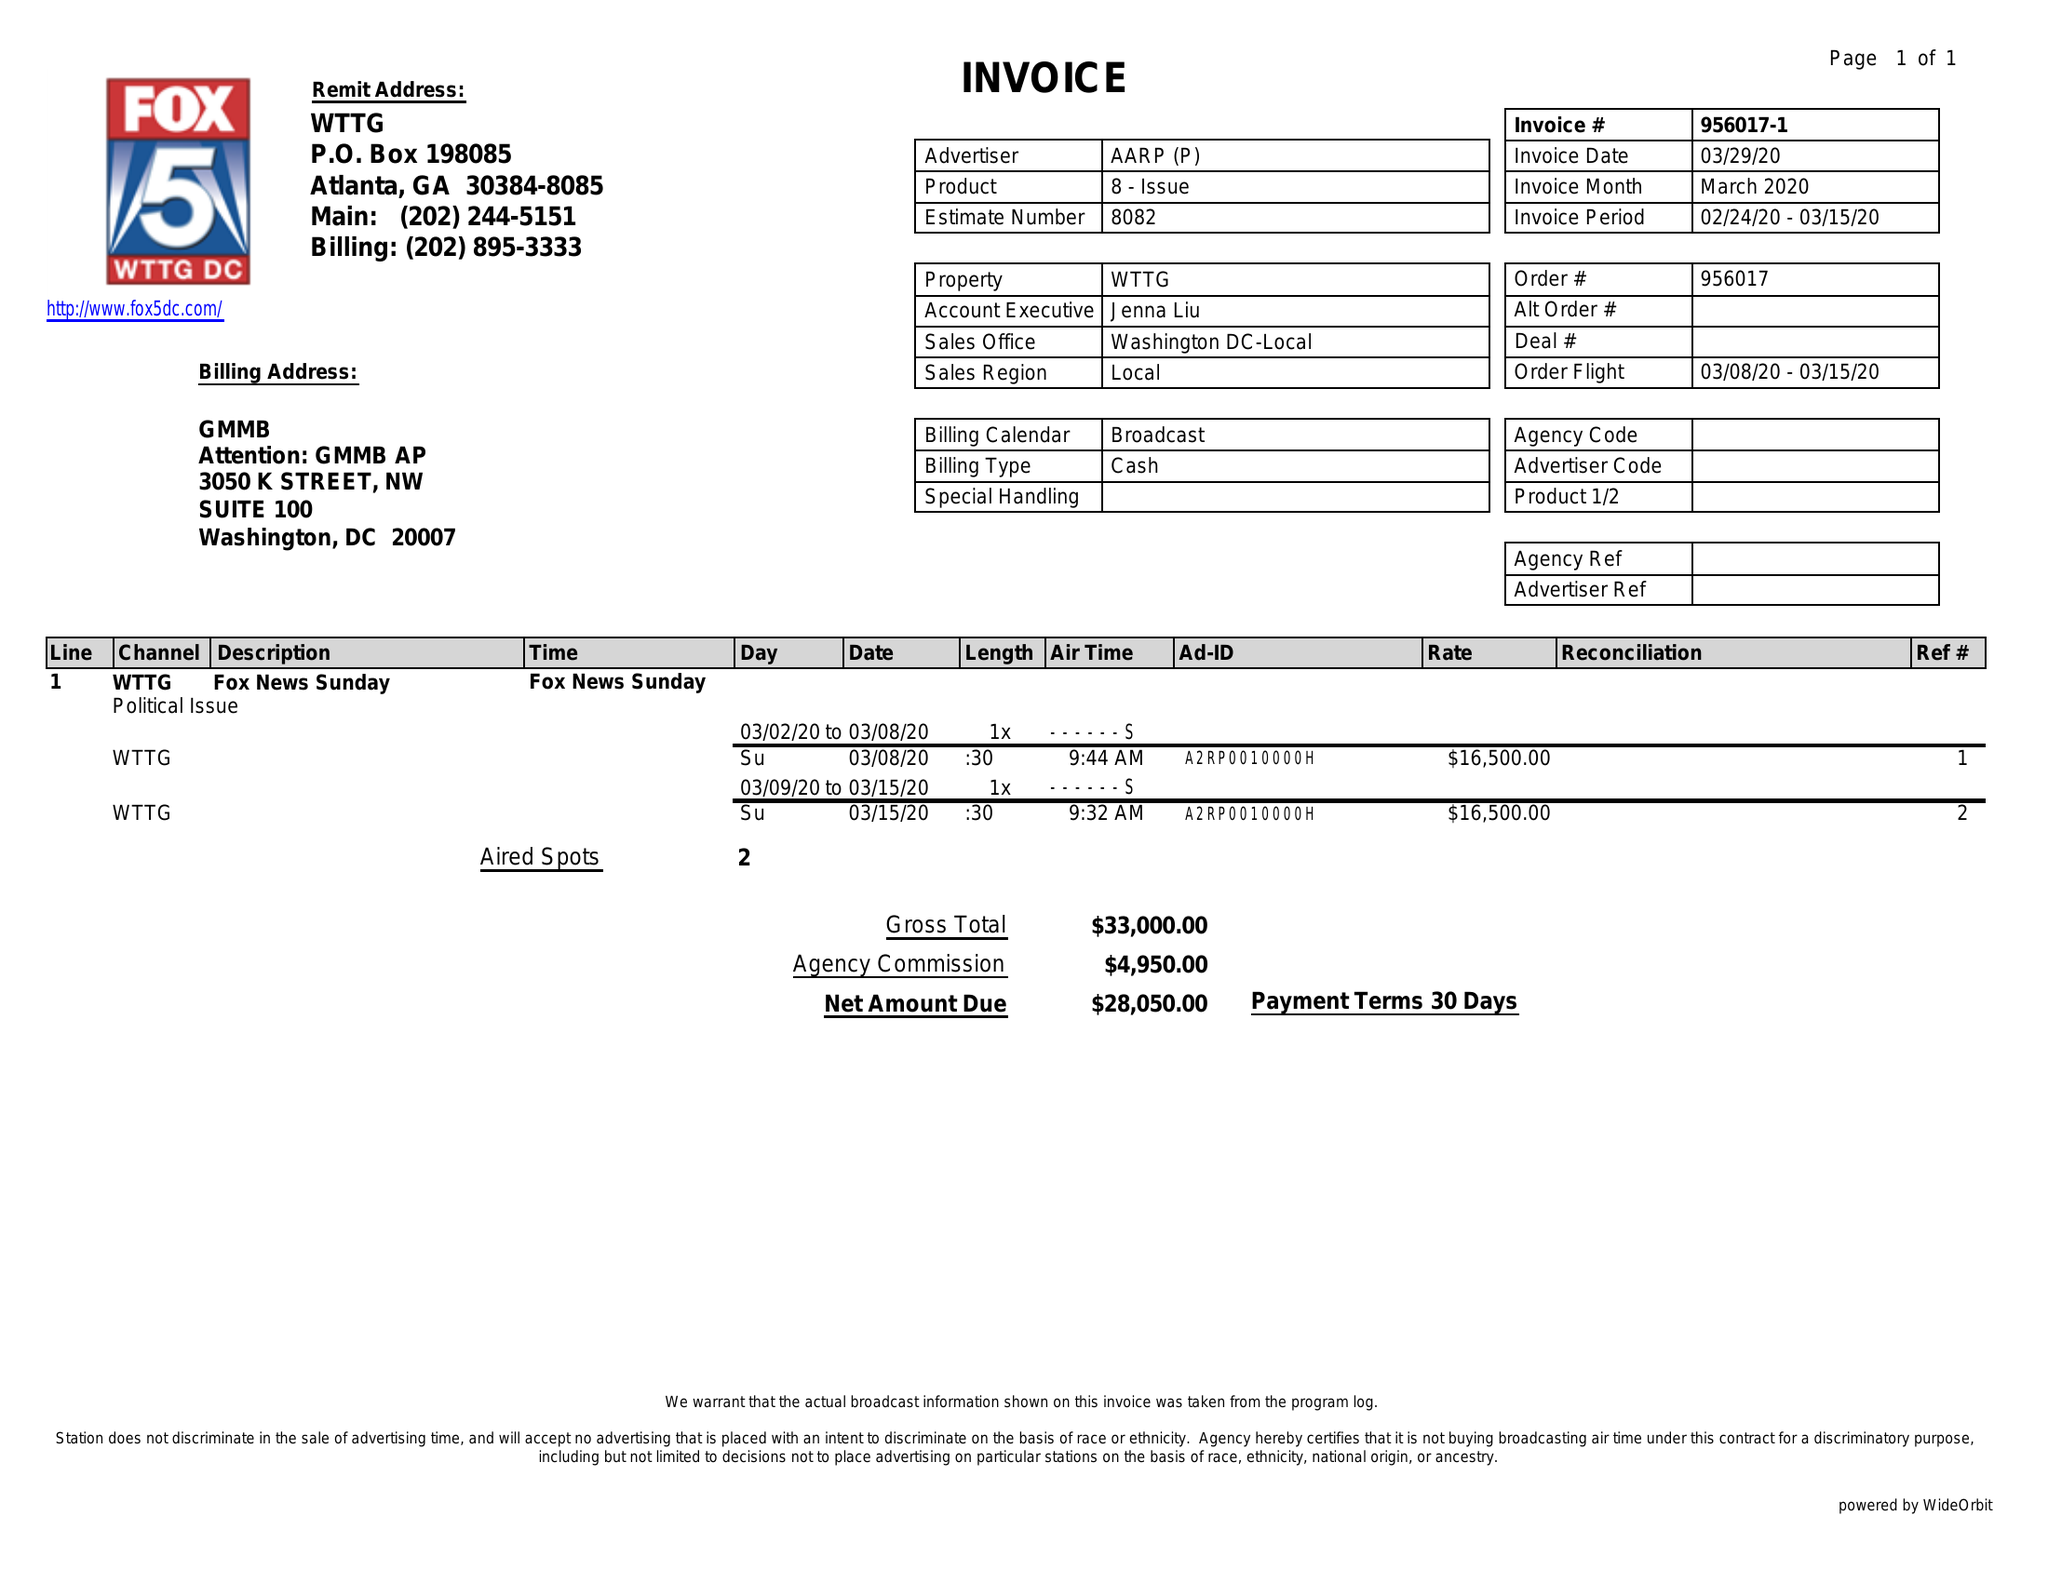What is the value for the advertiser?
Answer the question using a single word or phrase. AARP 